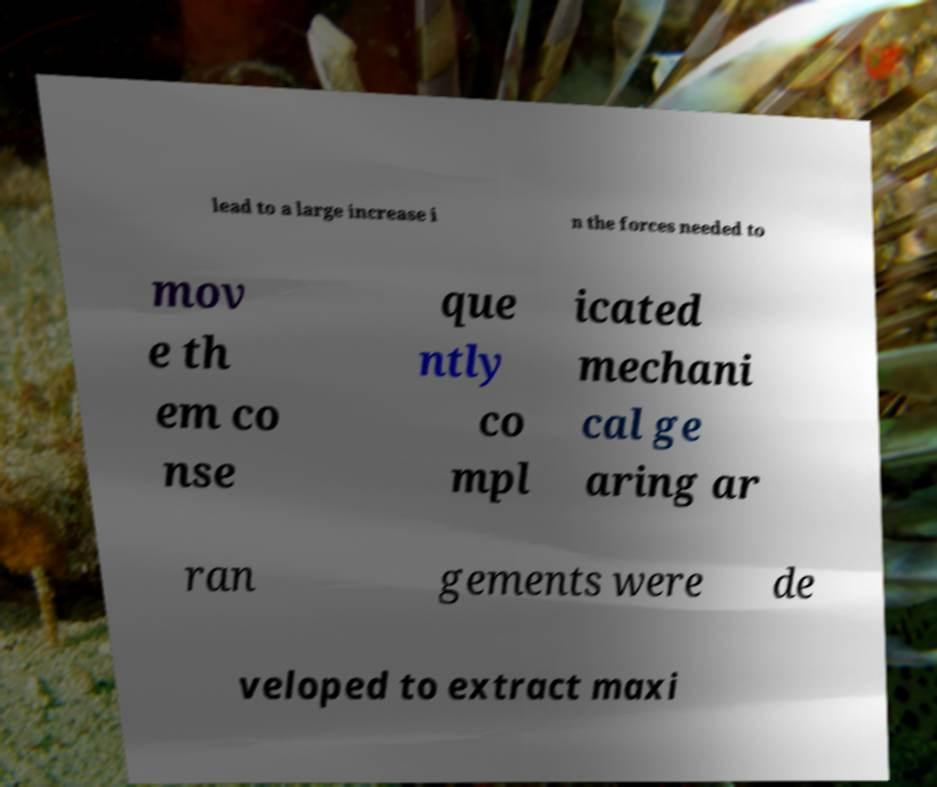Can you accurately transcribe the text from the provided image for me? lead to a large increase i n the forces needed to mov e th em co nse que ntly co mpl icated mechani cal ge aring ar ran gements were de veloped to extract maxi 